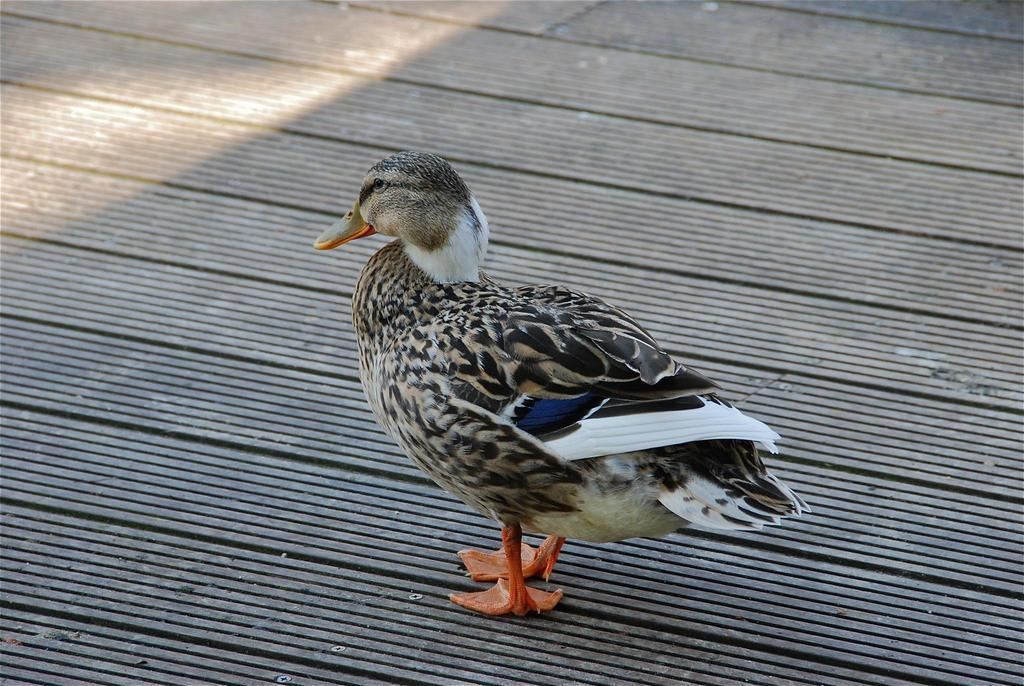What animal is present in the image? There is a duck in the image. Where is the duck located in the image? The duck is on the floor. What flavor of ice cream does the duck prefer? There is no information about the duck's ice cream preferences in the image, and the duck does not appear to be eating ice cream. 